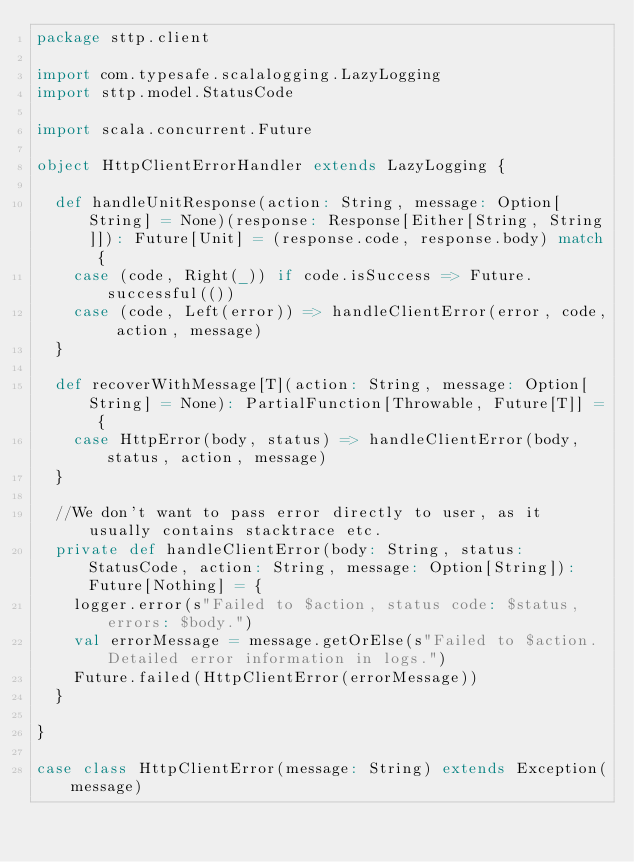Convert code to text. <code><loc_0><loc_0><loc_500><loc_500><_Scala_>package sttp.client

import com.typesafe.scalalogging.LazyLogging
import sttp.model.StatusCode

import scala.concurrent.Future

object HttpClientErrorHandler extends LazyLogging {

  def handleUnitResponse(action: String, message: Option[String] = None)(response: Response[Either[String, String]]): Future[Unit] = (response.code, response.body) match {
    case (code, Right(_)) if code.isSuccess => Future.successful(())
    case (code, Left(error)) => handleClientError(error, code, action, message)
  }

  def recoverWithMessage[T](action: String, message: Option[String] = None): PartialFunction[Throwable, Future[T]] = {
    case HttpError(body, status) => handleClientError(body, status, action, message)
  }

  //We don't want to pass error directly to user, as it usually contains stacktrace etc.
  private def handleClientError(body: String, status: StatusCode, action: String, message: Option[String]): Future[Nothing] = {
    logger.error(s"Failed to $action, status code: $status, errors: $body.")
    val errorMessage = message.getOrElse(s"Failed to $action. Detailed error information in logs.")
    Future.failed(HttpClientError(errorMessage))
  }

}

case class HttpClientError(message: String) extends Exception(message)
</code> 